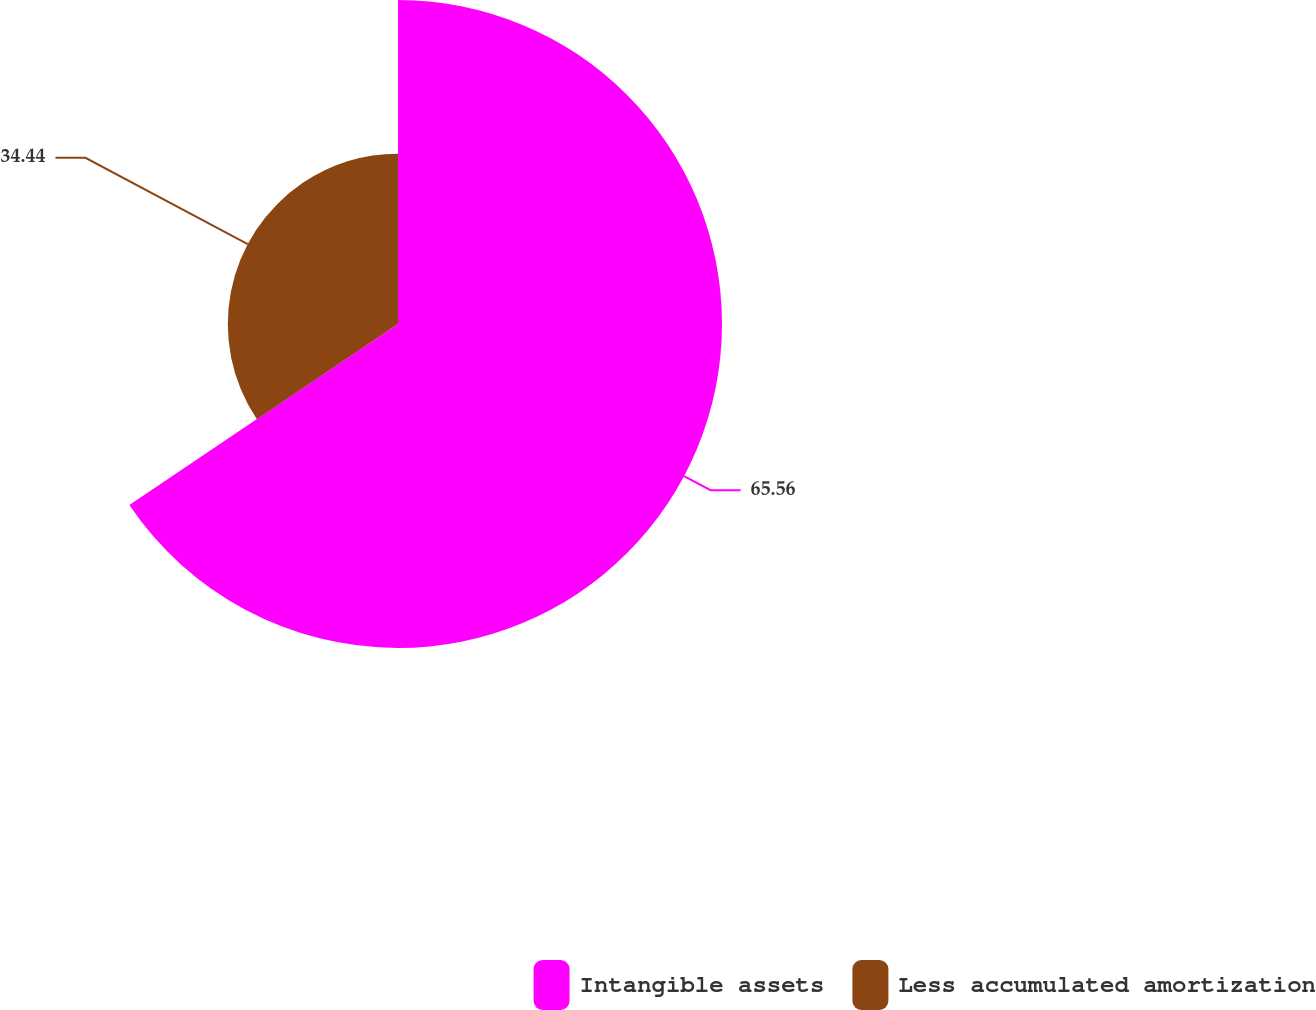Convert chart to OTSL. <chart><loc_0><loc_0><loc_500><loc_500><pie_chart><fcel>Intangible assets<fcel>Less accumulated amortization<nl><fcel>65.56%<fcel>34.44%<nl></chart> 